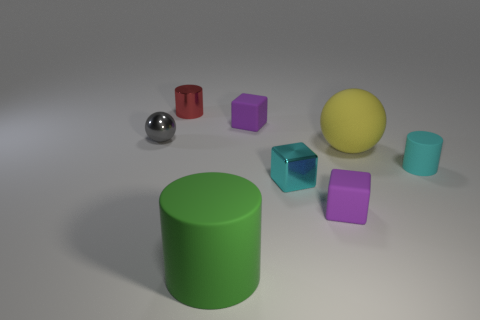Is the metallic cube the same color as the tiny rubber cylinder?
Give a very brief answer. Yes. How many blue objects are metal cubes or metal cylinders?
Provide a succinct answer. 0. Are there any matte cylinders of the same size as the green thing?
Offer a very short reply. No. How many tiny purple shiny spheres are there?
Your answer should be compact. 0. What number of tiny things are either purple rubber blocks or cyan matte things?
Give a very brief answer. 3. What color is the small metallic object on the right side of the rubber cylinder that is left of the purple matte cube that is to the right of the tiny cyan block?
Offer a terse response. Cyan. What number of other objects are the same color as the tiny shiny block?
Your answer should be very brief. 1. What number of shiny things are tiny red objects or purple cubes?
Provide a short and direct response. 1. Does the small rubber thing that is behind the gray shiny object have the same color as the matte cube that is in front of the matte ball?
Offer a terse response. Yes. There is a green object that is the same shape as the tiny cyan matte object; what is its size?
Your answer should be very brief. Large. 